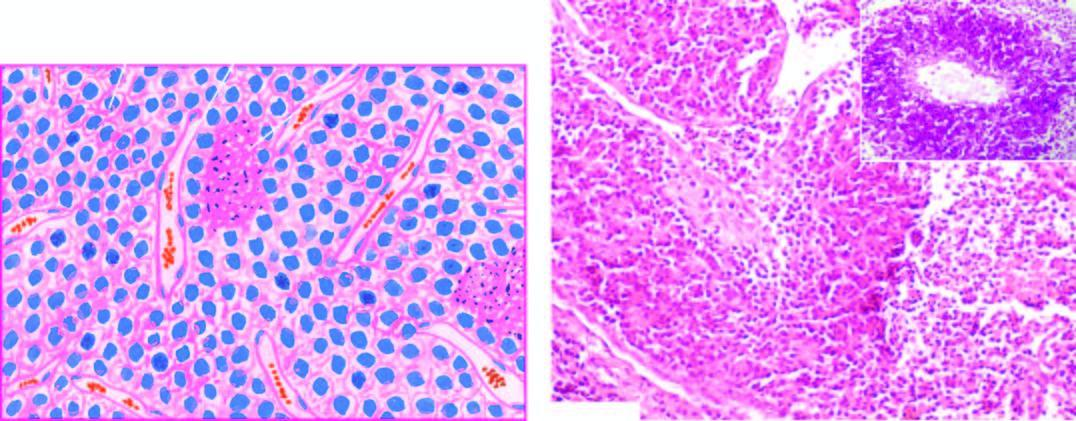re areas of necrosis and inflammatory infiltrate also included?
Answer the question using a single word or phrase. Yes 